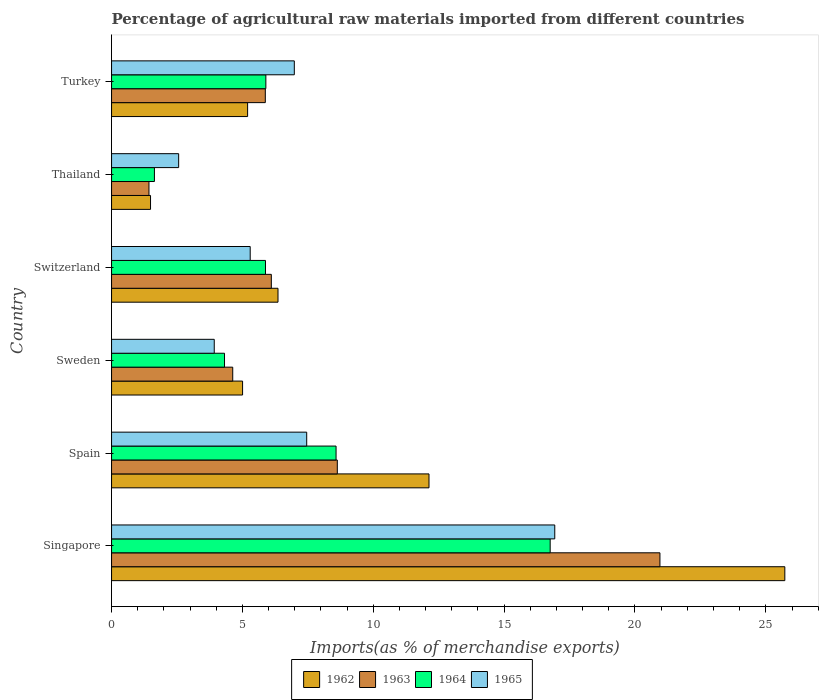Are the number of bars on each tick of the Y-axis equal?
Your answer should be compact. Yes. How many bars are there on the 4th tick from the bottom?
Offer a terse response. 4. What is the label of the 5th group of bars from the top?
Your answer should be very brief. Spain. What is the percentage of imports to different countries in 1963 in Turkey?
Offer a very short reply. 5.87. Across all countries, what is the maximum percentage of imports to different countries in 1964?
Offer a terse response. 16.76. Across all countries, what is the minimum percentage of imports to different countries in 1962?
Give a very brief answer. 1.49. In which country was the percentage of imports to different countries in 1963 maximum?
Your answer should be compact. Singapore. In which country was the percentage of imports to different countries in 1963 minimum?
Keep it short and to the point. Thailand. What is the total percentage of imports to different countries in 1965 in the graph?
Ensure brevity in your answer.  43.16. What is the difference between the percentage of imports to different countries in 1964 in Singapore and that in Turkey?
Ensure brevity in your answer.  10.86. What is the difference between the percentage of imports to different countries in 1962 in Turkey and the percentage of imports to different countries in 1965 in Sweden?
Offer a terse response. 1.27. What is the average percentage of imports to different countries in 1965 per country?
Offer a terse response. 7.19. What is the difference between the percentage of imports to different countries in 1962 and percentage of imports to different countries in 1965 in Thailand?
Your response must be concise. -1.08. What is the ratio of the percentage of imports to different countries in 1965 in Singapore to that in Turkey?
Ensure brevity in your answer.  2.43. Is the difference between the percentage of imports to different countries in 1962 in Singapore and Thailand greater than the difference between the percentage of imports to different countries in 1965 in Singapore and Thailand?
Make the answer very short. Yes. What is the difference between the highest and the second highest percentage of imports to different countries in 1962?
Offer a very short reply. 13.6. What is the difference between the highest and the lowest percentage of imports to different countries in 1963?
Your answer should be compact. 19.52. Is it the case that in every country, the sum of the percentage of imports to different countries in 1964 and percentage of imports to different countries in 1962 is greater than the sum of percentage of imports to different countries in 1965 and percentage of imports to different countries in 1963?
Give a very brief answer. No. What does the 1st bar from the top in Singapore represents?
Offer a terse response. 1965. What does the 1st bar from the bottom in Turkey represents?
Provide a succinct answer. 1962. Is it the case that in every country, the sum of the percentage of imports to different countries in 1962 and percentage of imports to different countries in 1965 is greater than the percentage of imports to different countries in 1964?
Offer a terse response. Yes. How many bars are there?
Provide a succinct answer. 24. Are all the bars in the graph horizontal?
Provide a succinct answer. Yes. How many countries are there in the graph?
Your answer should be very brief. 6. Does the graph contain grids?
Your answer should be compact. No. Where does the legend appear in the graph?
Your answer should be very brief. Bottom center. How many legend labels are there?
Your response must be concise. 4. How are the legend labels stacked?
Your response must be concise. Horizontal. What is the title of the graph?
Ensure brevity in your answer.  Percentage of agricultural raw materials imported from different countries. What is the label or title of the X-axis?
Give a very brief answer. Imports(as % of merchandise exports). What is the label or title of the Y-axis?
Give a very brief answer. Country. What is the Imports(as % of merchandise exports) of 1962 in Singapore?
Offer a very short reply. 25.73. What is the Imports(as % of merchandise exports) in 1963 in Singapore?
Your answer should be very brief. 20.95. What is the Imports(as % of merchandise exports) in 1964 in Singapore?
Your answer should be very brief. 16.76. What is the Imports(as % of merchandise exports) of 1965 in Singapore?
Provide a short and direct response. 16.93. What is the Imports(as % of merchandise exports) in 1962 in Spain?
Your response must be concise. 12.13. What is the Imports(as % of merchandise exports) in 1963 in Spain?
Offer a terse response. 8.63. What is the Imports(as % of merchandise exports) of 1964 in Spain?
Your response must be concise. 8.58. What is the Imports(as % of merchandise exports) in 1965 in Spain?
Keep it short and to the point. 7.46. What is the Imports(as % of merchandise exports) of 1962 in Sweden?
Offer a very short reply. 5.01. What is the Imports(as % of merchandise exports) of 1963 in Sweden?
Keep it short and to the point. 4.63. What is the Imports(as % of merchandise exports) of 1964 in Sweden?
Offer a very short reply. 4.32. What is the Imports(as % of merchandise exports) of 1965 in Sweden?
Offer a terse response. 3.92. What is the Imports(as % of merchandise exports) in 1962 in Switzerland?
Ensure brevity in your answer.  6.36. What is the Imports(as % of merchandise exports) in 1963 in Switzerland?
Provide a succinct answer. 6.1. What is the Imports(as % of merchandise exports) of 1964 in Switzerland?
Your answer should be very brief. 5.88. What is the Imports(as % of merchandise exports) in 1965 in Switzerland?
Make the answer very short. 5.3. What is the Imports(as % of merchandise exports) in 1962 in Thailand?
Offer a terse response. 1.49. What is the Imports(as % of merchandise exports) in 1963 in Thailand?
Keep it short and to the point. 1.43. What is the Imports(as % of merchandise exports) of 1964 in Thailand?
Your answer should be compact. 1.64. What is the Imports(as % of merchandise exports) in 1965 in Thailand?
Give a very brief answer. 2.56. What is the Imports(as % of merchandise exports) in 1962 in Turkey?
Your response must be concise. 5.2. What is the Imports(as % of merchandise exports) of 1963 in Turkey?
Ensure brevity in your answer.  5.87. What is the Imports(as % of merchandise exports) of 1964 in Turkey?
Your answer should be very brief. 5.9. What is the Imports(as % of merchandise exports) of 1965 in Turkey?
Provide a succinct answer. 6.98. Across all countries, what is the maximum Imports(as % of merchandise exports) of 1962?
Provide a short and direct response. 25.73. Across all countries, what is the maximum Imports(as % of merchandise exports) in 1963?
Provide a short and direct response. 20.95. Across all countries, what is the maximum Imports(as % of merchandise exports) in 1964?
Your answer should be very brief. 16.76. Across all countries, what is the maximum Imports(as % of merchandise exports) in 1965?
Keep it short and to the point. 16.93. Across all countries, what is the minimum Imports(as % of merchandise exports) in 1962?
Provide a short and direct response. 1.49. Across all countries, what is the minimum Imports(as % of merchandise exports) in 1963?
Your answer should be compact. 1.43. Across all countries, what is the minimum Imports(as % of merchandise exports) in 1964?
Ensure brevity in your answer.  1.64. Across all countries, what is the minimum Imports(as % of merchandise exports) of 1965?
Your answer should be compact. 2.56. What is the total Imports(as % of merchandise exports) in 1962 in the graph?
Keep it short and to the point. 55.91. What is the total Imports(as % of merchandise exports) in 1963 in the graph?
Offer a terse response. 47.62. What is the total Imports(as % of merchandise exports) in 1964 in the graph?
Provide a succinct answer. 43.07. What is the total Imports(as % of merchandise exports) of 1965 in the graph?
Give a very brief answer. 43.16. What is the difference between the Imports(as % of merchandise exports) in 1962 in Singapore and that in Spain?
Offer a very short reply. 13.6. What is the difference between the Imports(as % of merchandise exports) of 1963 in Singapore and that in Spain?
Offer a very short reply. 12.33. What is the difference between the Imports(as % of merchandise exports) in 1964 in Singapore and that in Spain?
Your answer should be compact. 8.18. What is the difference between the Imports(as % of merchandise exports) of 1965 in Singapore and that in Spain?
Provide a short and direct response. 9.48. What is the difference between the Imports(as % of merchandise exports) in 1962 in Singapore and that in Sweden?
Offer a very short reply. 20.72. What is the difference between the Imports(as % of merchandise exports) of 1963 in Singapore and that in Sweden?
Ensure brevity in your answer.  16.32. What is the difference between the Imports(as % of merchandise exports) in 1964 in Singapore and that in Sweden?
Ensure brevity in your answer.  12.44. What is the difference between the Imports(as % of merchandise exports) in 1965 in Singapore and that in Sweden?
Offer a terse response. 13.01. What is the difference between the Imports(as % of merchandise exports) in 1962 in Singapore and that in Switzerland?
Offer a terse response. 19.37. What is the difference between the Imports(as % of merchandise exports) of 1963 in Singapore and that in Switzerland?
Your answer should be very brief. 14.85. What is the difference between the Imports(as % of merchandise exports) in 1964 in Singapore and that in Switzerland?
Keep it short and to the point. 10.88. What is the difference between the Imports(as % of merchandise exports) in 1965 in Singapore and that in Switzerland?
Give a very brief answer. 11.64. What is the difference between the Imports(as % of merchandise exports) in 1962 in Singapore and that in Thailand?
Your answer should be compact. 24.24. What is the difference between the Imports(as % of merchandise exports) in 1963 in Singapore and that in Thailand?
Ensure brevity in your answer.  19.52. What is the difference between the Imports(as % of merchandise exports) in 1964 in Singapore and that in Thailand?
Give a very brief answer. 15.12. What is the difference between the Imports(as % of merchandise exports) of 1965 in Singapore and that in Thailand?
Offer a very short reply. 14.37. What is the difference between the Imports(as % of merchandise exports) of 1962 in Singapore and that in Turkey?
Provide a short and direct response. 20.53. What is the difference between the Imports(as % of merchandise exports) in 1963 in Singapore and that in Turkey?
Provide a short and direct response. 15.08. What is the difference between the Imports(as % of merchandise exports) in 1964 in Singapore and that in Turkey?
Your response must be concise. 10.86. What is the difference between the Imports(as % of merchandise exports) in 1965 in Singapore and that in Turkey?
Ensure brevity in your answer.  9.95. What is the difference between the Imports(as % of merchandise exports) of 1962 in Spain and that in Sweden?
Keep it short and to the point. 7.12. What is the difference between the Imports(as % of merchandise exports) of 1963 in Spain and that in Sweden?
Give a very brief answer. 4. What is the difference between the Imports(as % of merchandise exports) in 1964 in Spain and that in Sweden?
Your response must be concise. 4.26. What is the difference between the Imports(as % of merchandise exports) of 1965 in Spain and that in Sweden?
Offer a terse response. 3.53. What is the difference between the Imports(as % of merchandise exports) in 1962 in Spain and that in Switzerland?
Your answer should be compact. 5.77. What is the difference between the Imports(as % of merchandise exports) of 1963 in Spain and that in Switzerland?
Make the answer very short. 2.52. What is the difference between the Imports(as % of merchandise exports) in 1964 in Spain and that in Switzerland?
Provide a short and direct response. 2.7. What is the difference between the Imports(as % of merchandise exports) in 1965 in Spain and that in Switzerland?
Ensure brevity in your answer.  2.16. What is the difference between the Imports(as % of merchandise exports) of 1962 in Spain and that in Thailand?
Ensure brevity in your answer.  10.64. What is the difference between the Imports(as % of merchandise exports) in 1963 in Spain and that in Thailand?
Give a very brief answer. 7.2. What is the difference between the Imports(as % of merchandise exports) in 1964 in Spain and that in Thailand?
Your response must be concise. 6.94. What is the difference between the Imports(as % of merchandise exports) of 1965 in Spain and that in Thailand?
Make the answer very short. 4.89. What is the difference between the Imports(as % of merchandise exports) of 1962 in Spain and that in Turkey?
Make the answer very short. 6.93. What is the difference between the Imports(as % of merchandise exports) in 1963 in Spain and that in Turkey?
Provide a short and direct response. 2.75. What is the difference between the Imports(as % of merchandise exports) of 1964 in Spain and that in Turkey?
Your response must be concise. 2.68. What is the difference between the Imports(as % of merchandise exports) of 1965 in Spain and that in Turkey?
Your answer should be very brief. 0.47. What is the difference between the Imports(as % of merchandise exports) of 1962 in Sweden and that in Switzerland?
Your response must be concise. -1.35. What is the difference between the Imports(as % of merchandise exports) of 1963 in Sweden and that in Switzerland?
Your answer should be compact. -1.47. What is the difference between the Imports(as % of merchandise exports) in 1964 in Sweden and that in Switzerland?
Your answer should be compact. -1.57. What is the difference between the Imports(as % of merchandise exports) of 1965 in Sweden and that in Switzerland?
Ensure brevity in your answer.  -1.37. What is the difference between the Imports(as % of merchandise exports) in 1962 in Sweden and that in Thailand?
Your answer should be very brief. 3.52. What is the difference between the Imports(as % of merchandise exports) in 1963 in Sweden and that in Thailand?
Your answer should be compact. 3.2. What is the difference between the Imports(as % of merchandise exports) in 1964 in Sweden and that in Thailand?
Ensure brevity in your answer.  2.68. What is the difference between the Imports(as % of merchandise exports) of 1965 in Sweden and that in Thailand?
Your answer should be very brief. 1.36. What is the difference between the Imports(as % of merchandise exports) of 1962 in Sweden and that in Turkey?
Your response must be concise. -0.19. What is the difference between the Imports(as % of merchandise exports) of 1963 in Sweden and that in Turkey?
Provide a succinct answer. -1.24. What is the difference between the Imports(as % of merchandise exports) in 1964 in Sweden and that in Turkey?
Keep it short and to the point. -1.58. What is the difference between the Imports(as % of merchandise exports) of 1965 in Sweden and that in Turkey?
Your answer should be very brief. -3.06. What is the difference between the Imports(as % of merchandise exports) in 1962 in Switzerland and that in Thailand?
Ensure brevity in your answer.  4.87. What is the difference between the Imports(as % of merchandise exports) in 1963 in Switzerland and that in Thailand?
Offer a very short reply. 4.68. What is the difference between the Imports(as % of merchandise exports) of 1964 in Switzerland and that in Thailand?
Make the answer very short. 4.24. What is the difference between the Imports(as % of merchandise exports) of 1965 in Switzerland and that in Thailand?
Make the answer very short. 2.73. What is the difference between the Imports(as % of merchandise exports) in 1962 in Switzerland and that in Turkey?
Provide a short and direct response. 1.16. What is the difference between the Imports(as % of merchandise exports) of 1963 in Switzerland and that in Turkey?
Keep it short and to the point. 0.23. What is the difference between the Imports(as % of merchandise exports) in 1964 in Switzerland and that in Turkey?
Your answer should be compact. -0.01. What is the difference between the Imports(as % of merchandise exports) in 1965 in Switzerland and that in Turkey?
Make the answer very short. -1.69. What is the difference between the Imports(as % of merchandise exports) of 1962 in Thailand and that in Turkey?
Your answer should be very brief. -3.71. What is the difference between the Imports(as % of merchandise exports) of 1963 in Thailand and that in Turkey?
Your response must be concise. -4.45. What is the difference between the Imports(as % of merchandise exports) of 1964 in Thailand and that in Turkey?
Offer a very short reply. -4.26. What is the difference between the Imports(as % of merchandise exports) of 1965 in Thailand and that in Turkey?
Make the answer very short. -4.42. What is the difference between the Imports(as % of merchandise exports) in 1962 in Singapore and the Imports(as % of merchandise exports) in 1963 in Spain?
Offer a very short reply. 17.1. What is the difference between the Imports(as % of merchandise exports) of 1962 in Singapore and the Imports(as % of merchandise exports) of 1964 in Spain?
Ensure brevity in your answer.  17.15. What is the difference between the Imports(as % of merchandise exports) of 1962 in Singapore and the Imports(as % of merchandise exports) of 1965 in Spain?
Ensure brevity in your answer.  18.27. What is the difference between the Imports(as % of merchandise exports) of 1963 in Singapore and the Imports(as % of merchandise exports) of 1964 in Spain?
Your answer should be compact. 12.38. What is the difference between the Imports(as % of merchandise exports) of 1963 in Singapore and the Imports(as % of merchandise exports) of 1965 in Spain?
Offer a very short reply. 13.5. What is the difference between the Imports(as % of merchandise exports) of 1964 in Singapore and the Imports(as % of merchandise exports) of 1965 in Spain?
Offer a terse response. 9.3. What is the difference between the Imports(as % of merchandise exports) of 1962 in Singapore and the Imports(as % of merchandise exports) of 1963 in Sweden?
Provide a short and direct response. 21.09. What is the difference between the Imports(as % of merchandise exports) in 1962 in Singapore and the Imports(as % of merchandise exports) in 1964 in Sweden?
Provide a succinct answer. 21.41. What is the difference between the Imports(as % of merchandise exports) of 1962 in Singapore and the Imports(as % of merchandise exports) of 1965 in Sweden?
Your answer should be compact. 21.8. What is the difference between the Imports(as % of merchandise exports) in 1963 in Singapore and the Imports(as % of merchandise exports) in 1964 in Sweden?
Make the answer very short. 16.64. What is the difference between the Imports(as % of merchandise exports) of 1963 in Singapore and the Imports(as % of merchandise exports) of 1965 in Sweden?
Make the answer very short. 17.03. What is the difference between the Imports(as % of merchandise exports) in 1964 in Singapore and the Imports(as % of merchandise exports) in 1965 in Sweden?
Provide a succinct answer. 12.83. What is the difference between the Imports(as % of merchandise exports) in 1962 in Singapore and the Imports(as % of merchandise exports) in 1963 in Switzerland?
Your answer should be very brief. 19.62. What is the difference between the Imports(as % of merchandise exports) of 1962 in Singapore and the Imports(as % of merchandise exports) of 1964 in Switzerland?
Provide a succinct answer. 19.84. What is the difference between the Imports(as % of merchandise exports) in 1962 in Singapore and the Imports(as % of merchandise exports) in 1965 in Switzerland?
Ensure brevity in your answer.  20.43. What is the difference between the Imports(as % of merchandise exports) in 1963 in Singapore and the Imports(as % of merchandise exports) in 1964 in Switzerland?
Make the answer very short. 15.07. What is the difference between the Imports(as % of merchandise exports) of 1963 in Singapore and the Imports(as % of merchandise exports) of 1965 in Switzerland?
Keep it short and to the point. 15.66. What is the difference between the Imports(as % of merchandise exports) of 1964 in Singapore and the Imports(as % of merchandise exports) of 1965 in Switzerland?
Your response must be concise. 11.46. What is the difference between the Imports(as % of merchandise exports) of 1962 in Singapore and the Imports(as % of merchandise exports) of 1963 in Thailand?
Provide a short and direct response. 24.3. What is the difference between the Imports(as % of merchandise exports) of 1962 in Singapore and the Imports(as % of merchandise exports) of 1964 in Thailand?
Offer a very short reply. 24.09. What is the difference between the Imports(as % of merchandise exports) in 1962 in Singapore and the Imports(as % of merchandise exports) in 1965 in Thailand?
Offer a very short reply. 23.16. What is the difference between the Imports(as % of merchandise exports) in 1963 in Singapore and the Imports(as % of merchandise exports) in 1964 in Thailand?
Keep it short and to the point. 19.32. What is the difference between the Imports(as % of merchandise exports) of 1963 in Singapore and the Imports(as % of merchandise exports) of 1965 in Thailand?
Offer a very short reply. 18.39. What is the difference between the Imports(as % of merchandise exports) in 1964 in Singapore and the Imports(as % of merchandise exports) in 1965 in Thailand?
Provide a succinct answer. 14.2. What is the difference between the Imports(as % of merchandise exports) of 1962 in Singapore and the Imports(as % of merchandise exports) of 1963 in Turkey?
Your answer should be very brief. 19.85. What is the difference between the Imports(as % of merchandise exports) of 1962 in Singapore and the Imports(as % of merchandise exports) of 1964 in Turkey?
Give a very brief answer. 19.83. What is the difference between the Imports(as % of merchandise exports) of 1962 in Singapore and the Imports(as % of merchandise exports) of 1965 in Turkey?
Keep it short and to the point. 18.74. What is the difference between the Imports(as % of merchandise exports) of 1963 in Singapore and the Imports(as % of merchandise exports) of 1964 in Turkey?
Offer a terse response. 15.06. What is the difference between the Imports(as % of merchandise exports) of 1963 in Singapore and the Imports(as % of merchandise exports) of 1965 in Turkey?
Give a very brief answer. 13.97. What is the difference between the Imports(as % of merchandise exports) in 1964 in Singapore and the Imports(as % of merchandise exports) in 1965 in Turkey?
Your response must be concise. 9.78. What is the difference between the Imports(as % of merchandise exports) in 1962 in Spain and the Imports(as % of merchandise exports) in 1963 in Sweden?
Keep it short and to the point. 7.5. What is the difference between the Imports(as % of merchandise exports) in 1962 in Spain and the Imports(as % of merchandise exports) in 1964 in Sweden?
Provide a succinct answer. 7.81. What is the difference between the Imports(as % of merchandise exports) of 1962 in Spain and the Imports(as % of merchandise exports) of 1965 in Sweden?
Offer a very short reply. 8.21. What is the difference between the Imports(as % of merchandise exports) in 1963 in Spain and the Imports(as % of merchandise exports) in 1964 in Sweden?
Give a very brief answer. 4.31. What is the difference between the Imports(as % of merchandise exports) of 1963 in Spain and the Imports(as % of merchandise exports) of 1965 in Sweden?
Provide a succinct answer. 4.7. What is the difference between the Imports(as % of merchandise exports) of 1964 in Spain and the Imports(as % of merchandise exports) of 1965 in Sweden?
Provide a succinct answer. 4.65. What is the difference between the Imports(as % of merchandise exports) in 1962 in Spain and the Imports(as % of merchandise exports) in 1963 in Switzerland?
Offer a terse response. 6.02. What is the difference between the Imports(as % of merchandise exports) of 1962 in Spain and the Imports(as % of merchandise exports) of 1964 in Switzerland?
Give a very brief answer. 6.25. What is the difference between the Imports(as % of merchandise exports) in 1962 in Spain and the Imports(as % of merchandise exports) in 1965 in Switzerland?
Your response must be concise. 6.83. What is the difference between the Imports(as % of merchandise exports) of 1963 in Spain and the Imports(as % of merchandise exports) of 1964 in Switzerland?
Provide a short and direct response. 2.74. What is the difference between the Imports(as % of merchandise exports) in 1963 in Spain and the Imports(as % of merchandise exports) in 1965 in Switzerland?
Make the answer very short. 3.33. What is the difference between the Imports(as % of merchandise exports) of 1964 in Spain and the Imports(as % of merchandise exports) of 1965 in Switzerland?
Keep it short and to the point. 3.28. What is the difference between the Imports(as % of merchandise exports) of 1962 in Spain and the Imports(as % of merchandise exports) of 1963 in Thailand?
Your answer should be compact. 10.7. What is the difference between the Imports(as % of merchandise exports) of 1962 in Spain and the Imports(as % of merchandise exports) of 1964 in Thailand?
Your answer should be compact. 10.49. What is the difference between the Imports(as % of merchandise exports) of 1962 in Spain and the Imports(as % of merchandise exports) of 1965 in Thailand?
Your response must be concise. 9.57. What is the difference between the Imports(as % of merchandise exports) in 1963 in Spain and the Imports(as % of merchandise exports) in 1964 in Thailand?
Offer a very short reply. 6.99. What is the difference between the Imports(as % of merchandise exports) of 1963 in Spain and the Imports(as % of merchandise exports) of 1965 in Thailand?
Your response must be concise. 6.06. What is the difference between the Imports(as % of merchandise exports) in 1964 in Spain and the Imports(as % of merchandise exports) in 1965 in Thailand?
Provide a succinct answer. 6.01. What is the difference between the Imports(as % of merchandise exports) of 1962 in Spain and the Imports(as % of merchandise exports) of 1963 in Turkey?
Ensure brevity in your answer.  6.25. What is the difference between the Imports(as % of merchandise exports) of 1962 in Spain and the Imports(as % of merchandise exports) of 1964 in Turkey?
Your answer should be compact. 6.23. What is the difference between the Imports(as % of merchandise exports) of 1962 in Spain and the Imports(as % of merchandise exports) of 1965 in Turkey?
Your response must be concise. 5.15. What is the difference between the Imports(as % of merchandise exports) in 1963 in Spain and the Imports(as % of merchandise exports) in 1964 in Turkey?
Make the answer very short. 2.73. What is the difference between the Imports(as % of merchandise exports) in 1963 in Spain and the Imports(as % of merchandise exports) in 1965 in Turkey?
Your answer should be very brief. 1.64. What is the difference between the Imports(as % of merchandise exports) of 1964 in Spain and the Imports(as % of merchandise exports) of 1965 in Turkey?
Offer a terse response. 1.6. What is the difference between the Imports(as % of merchandise exports) in 1962 in Sweden and the Imports(as % of merchandise exports) in 1963 in Switzerland?
Offer a very short reply. -1.1. What is the difference between the Imports(as % of merchandise exports) of 1962 in Sweden and the Imports(as % of merchandise exports) of 1964 in Switzerland?
Your answer should be compact. -0.88. What is the difference between the Imports(as % of merchandise exports) in 1962 in Sweden and the Imports(as % of merchandise exports) in 1965 in Switzerland?
Make the answer very short. -0.29. What is the difference between the Imports(as % of merchandise exports) of 1963 in Sweden and the Imports(as % of merchandise exports) of 1964 in Switzerland?
Provide a short and direct response. -1.25. What is the difference between the Imports(as % of merchandise exports) of 1963 in Sweden and the Imports(as % of merchandise exports) of 1965 in Switzerland?
Keep it short and to the point. -0.67. What is the difference between the Imports(as % of merchandise exports) in 1964 in Sweden and the Imports(as % of merchandise exports) in 1965 in Switzerland?
Offer a very short reply. -0.98. What is the difference between the Imports(as % of merchandise exports) of 1962 in Sweden and the Imports(as % of merchandise exports) of 1963 in Thailand?
Provide a succinct answer. 3.58. What is the difference between the Imports(as % of merchandise exports) of 1962 in Sweden and the Imports(as % of merchandise exports) of 1964 in Thailand?
Ensure brevity in your answer.  3.37. What is the difference between the Imports(as % of merchandise exports) in 1962 in Sweden and the Imports(as % of merchandise exports) in 1965 in Thailand?
Offer a terse response. 2.44. What is the difference between the Imports(as % of merchandise exports) in 1963 in Sweden and the Imports(as % of merchandise exports) in 1964 in Thailand?
Your answer should be compact. 2.99. What is the difference between the Imports(as % of merchandise exports) in 1963 in Sweden and the Imports(as % of merchandise exports) in 1965 in Thailand?
Your answer should be very brief. 2.07. What is the difference between the Imports(as % of merchandise exports) in 1964 in Sweden and the Imports(as % of merchandise exports) in 1965 in Thailand?
Offer a very short reply. 1.75. What is the difference between the Imports(as % of merchandise exports) in 1962 in Sweden and the Imports(as % of merchandise exports) in 1963 in Turkey?
Your answer should be compact. -0.87. What is the difference between the Imports(as % of merchandise exports) in 1962 in Sweden and the Imports(as % of merchandise exports) in 1964 in Turkey?
Give a very brief answer. -0.89. What is the difference between the Imports(as % of merchandise exports) of 1962 in Sweden and the Imports(as % of merchandise exports) of 1965 in Turkey?
Your response must be concise. -1.98. What is the difference between the Imports(as % of merchandise exports) in 1963 in Sweden and the Imports(as % of merchandise exports) in 1964 in Turkey?
Offer a terse response. -1.27. What is the difference between the Imports(as % of merchandise exports) of 1963 in Sweden and the Imports(as % of merchandise exports) of 1965 in Turkey?
Offer a terse response. -2.35. What is the difference between the Imports(as % of merchandise exports) of 1964 in Sweden and the Imports(as % of merchandise exports) of 1965 in Turkey?
Your answer should be very brief. -2.67. What is the difference between the Imports(as % of merchandise exports) in 1962 in Switzerland and the Imports(as % of merchandise exports) in 1963 in Thailand?
Provide a short and direct response. 4.93. What is the difference between the Imports(as % of merchandise exports) in 1962 in Switzerland and the Imports(as % of merchandise exports) in 1964 in Thailand?
Give a very brief answer. 4.72. What is the difference between the Imports(as % of merchandise exports) in 1962 in Switzerland and the Imports(as % of merchandise exports) in 1965 in Thailand?
Your answer should be compact. 3.8. What is the difference between the Imports(as % of merchandise exports) of 1963 in Switzerland and the Imports(as % of merchandise exports) of 1964 in Thailand?
Keep it short and to the point. 4.47. What is the difference between the Imports(as % of merchandise exports) of 1963 in Switzerland and the Imports(as % of merchandise exports) of 1965 in Thailand?
Your answer should be compact. 3.54. What is the difference between the Imports(as % of merchandise exports) of 1964 in Switzerland and the Imports(as % of merchandise exports) of 1965 in Thailand?
Your response must be concise. 3.32. What is the difference between the Imports(as % of merchandise exports) in 1962 in Switzerland and the Imports(as % of merchandise exports) in 1963 in Turkey?
Ensure brevity in your answer.  0.49. What is the difference between the Imports(as % of merchandise exports) in 1962 in Switzerland and the Imports(as % of merchandise exports) in 1964 in Turkey?
Give a very brief answer. 0.46. What is the difference between the Imports(as % of merchandise exports) of 1962 in Switzerland and the Imports(as % of merchandise exports) of 1965 in Turkey?
Ensure brevity in your answer.  -0.62. What is the difference between the Imports(as % of merchandise exports) of 1963 in Switzerland and the Imports(as % of merchandise exports) of 1964 in Turkey?
Provide a short and direct response. 0.21. What is the difference between the Imports(as % of merchandise exports) of 1963 in Switzerland and the Imports(as % of merchandise exports) of 1965 in Turkey?
Provide a short and direct response. -0.88. What is the difference between the Imports(as % of merchandise exports) in 1964 in Switzerland and the Imports(as % of merchandise exports) in 1965 in Turkey?
Keep it short and to the point. -1.1. What is the difference between the Imports(as % of merchandise exports) of 1962 in Thailand and the Imports(as % of merchandise exports) of 1963 in Turkey?
Ensure brevity in your answer.  -4.39. What is the difference between the Imports(as % of merchandise exports) in 1962 in Thailand and the Imports(as % of merchandise exports) in 1964 in Turkey?
Make the answer very short. -4.41. What is the difference between the Imports(as % of merchandise exports) of 1962 in Thailand and the Imports(as % of merchandise exports) of 1965 in Turkey?
Offer a very short reply. -5.49. What is the difference between the Imports(as % of merchandise exports) of 1963 in Thailand and the Imports(as % of merchandise exports) of 1964 in Turkey?
Make the answer very short. -4.47. What is the difference between the Imports(as % of merchandise exports) of 1963 in Thailand and the Imports(as % of merchandise exports) of 1965 in Turkey?
Your answer should be compact. -5.55. What is the difference between the Imports(as % of merchandise exports) of 1964 in Thailand and the Imports(as % of merchandise exports) of 1965 in Turkey?
Ensure brevity in your answer.  -5.35. What is the average Imports(as % of merchandise exports) of 1962 per country?
Provide a short and direct response. 9.32. What is the average Imports(as % of merchandise exports) of 1963 per country?
Your answer should be very brief. 7.94. What is the average Imports(as % of merchandise exports) of 1964 per country?
Make the answer very short. 7.18. What is the average Imports(as % of merchandise exports) of 1965 per country?
Make the answer very short. 7.19. What is the difference between the Imports(as % of merchandise exports) in 1962 and Imports(as % of merchandise exports) in 1963 in Singapore?
Offer a very short reply. 4.77. What is the difference between the Imports(as % of merchandise exports) in 1962 and Imports(as % of merchandise exports) in 1964 in Singapore?
Your response must be concise. 8.97. What is the difference between the Imports(as % of merchandise exports) of 1962 and Imports(as % of merchandise exports) of 1965 in Singapore?
Provide a succinct answer. 8.79. What is the difference between the Imports(as % of merchandise exports) in 1963 and Imports(as % of merchandise exports) in 1964 in Singapore?
Provide a succinct answer. 4.19. What is the difference between the Imports(as % of merchandise exports) in 1963 and Imports(as % of merchandise exports) in 1965 in Singapore?
Offer a terse response. 4.02. What is the difference between the Imports(as % of merchandise exports) in 1964 and Imports(as % of merchandise exports) in 1965 in Singapore?
Make the answer very short. -0.18. What is the difference between the Imports(as % of merchandise exports) in 1962 and Imports(as % of merchandise exports) in 1963 in Spain?
Your answer should be compact. 3.5. What is the difference between the Imports(as % of merchandise exports) of 1962 and Imports(as % of merchandise exports) of 1964 in Spain?
Ensure brevity in your answer.  3.55. What is the difference between the Imports(as % of merchandise exports) of 1962 and Imports(as % of merchandise exports) of 1965 in Spain?
Keep it short and to the point. 4.67. What is the difference between the Imports(as % of merchandise exports) of 1963 and Imports(as % of merchandise exports) of 1964 in Spain?
Offer a terse response. 0.05. What is the difference between the Imports(as % of merchandise exports) in 1963 and Imports(as % of merchandise exports) in 1965 in Spain?
Give a very brief answer. 1.17. What is the difference between the Imports(as % of merchandise exports) in 1964 and Imports(as % of merchandise exports) in 1965 in Spain?
Make the answer very short. 1.12. What is the difference between the Imports(as % of merchandise exports) of 1962 and Imports(as % of merchandise exports) of 1963 in Sweden?
Offer a terse response. 0.38. What is the difference between the Imports(as % of merchandise exports) in 1962 and Imports(as % of merchandise exports) in 1964 in Sweden?
Provide a short and direct response. 0.69. What is the difference between the Imports(as % of merchandise exports) in 1962 and Imports(as % of merchandise exports) in 1965 in Sweden?
Make the answer very short. 1.08. What is the difference between the Imports(as % of merchandise exports) of 1963 and Imports(as % of merchandise exports) of 1964 in Sweden?
Your answer should be very brief. 0.31. What is the difference between the Imports(as % of merchandise exports) of 1963 and Imports(as % of merchandise exports) of 1965 in Sweden?
Give a very brief answer. 0.71. What is the difference between the Imports(as % of merchandise exports) in 1964 and Imports(as % of merchandise exports) in 1965 in Sweden?
Provide a succinct answer. 0.39. What is the difference between the Imports(as % of merchandise exports) of 1962 and Imports(as % of merchandise exports) of 1963 in Switzerland?
Ensure brevity in your answer.  0.26. What is the difference between the Imports(as % of merchandise exports) in 1962 and Imports(as % of merchandise exports) in 1964 in Switzerland?
Your answer should be compact. 0.48. What is the difference between the Imports(as % of merchandise exports) in 1962 and Imports(as % of merchandise exports) in 1965 in Switzerland?
Your answer should be very brief. 1.06. What is the difference between the Imports(as % of merchandise exports) in 1963 and Imports(as % of merchandise exports) in 1964 in Switzerland?
Provide a succinct answer. 0.22. What is the difference between the Imports(as % of merchandise exports) in 1963 and Imports(as % of merchandise exports) in 1965 in Switzerland?
Your answer should be very brief. 0.81. What is the difference between the Imports(as % of merchandise exports) in 1964 and Imports(as % of merchandise exports) in 1965 in Switzerland?
Provide a succinct answer. 0.58. What is the difference between the Imports(as % of merchandise exports) in 1962 and Imports(as % of merchandise exports) in 1963 in Thailand?
Provide a short and direct response. 0.06. What is the difference between the Imports(as % of merchandise exports) of 1962 and Imports(as % of merchandise exports) of 1964 in Thailand?
Offer a terse response. -0.15. What is the difference between the Imports(as % of merchandise exports) of 1962 and Imports(as % of merchandise exports) of 1965 in Thailand?
Your answer should be compact. -1.08. What is the difference between the Imports(as % of merchandise exports) in 1963 and Imports(as % of merchandise exports) in 1964 in Thailand?
Offer a very short reply. -0.21. What is the difference between the Imports(as % of merchandise exports) in 1963 and Imports(as % of merchandise exports) in 1965 in Thailand?
Keep it short and to the point. -1.13. What is the difference between the Imports(as % of merchandise exports) in 1964 and Imports(as % of merchandise exports) in 1965 in Thailand?
Offer a terse response. -0.93. What is the difference between the Imports(as % of merchandise exports) of 1962 and Imports(as % of merchandise exports) of 1963 in Turkey?
Ensure brevity in your answer.  -0.68. What is the difference between the Imports(as % of merchandise exports) in 1962 and Imports(as % of merchandise exports) in 1964 in Turkey?
Ensure brevity in your answer.  -0.7. What is the difference between the Imports(as % of merchandise exports) of 1962 and Imports(as % of merchandise exports) of 1965 in Turkey?
Provide a succinct answer. -1.78. What is the difference between the Imports(as % of merchandise exports) in 1963 and Imports(as % of merchandise exports) in 1964 in Turkey?
Offer a terse response. -0.02. What is the difference between the Imports(as % of merchandise exports) of 1963 and Imports(as % of merchandise exports) of 1965 in Turkey?
Provide a short and direct response. -1.11. What is the difference between the Imports(as % of merchandise exports) of 1964 and Imports(as % of merchandise exports) of 1965 in Turkey?
Ensure brevity in your answer.  -1.09. What is the ratio of the Imports(as % of merchandise exports) in 1962 in Singapore to that in Spain?
Your answer should be compact. 2.12. What is the ratio of the Imports(as % of merchandise exports) in 1963 in Singapore to that in Spain?
Your answer should be very brief. 2.43. What is the ratio of the Imports(as % of merchandise exports) in 1964 in Singapore to that in Spain?
Give a very brief answer. 1.95. What is the ratio of the Imports(as % of merchandise exports) in 1965 in Singapore to that in Spain?
Your answer should be compact. 2.27. What is the ratio of the Imports(as % of merchandise exports) in 1962 in Singapore to that in Sweden?
Give a very brief answer. 5.14. What is the ratio of the Imports(as % of merchandise exports) in 1963 in Singapore to that in Sweden?
Provide a succinct answer. 4.53. What is the ratio of the Imports(as % of merchandise exports) in 1964 in Singapore to that in Sweden?
Your response must be concise. 3.88. What is the ratio of the Imports(as % of merchandise exports) in 1965 in Singapore to that in Sweden?
Provide a succinct answer. 4.32. What is the ratio of the Imports(as % of merchandise exports) in 1962 in Singapore to that in Switzerland?
Your answer should be compact. 4.04. What is the ratio of the Imports(as % of merchandise exports) in 1963 in Singapore to that in Switzerland?
Give a very brief answer. 3.43. What is the ratio of the Imports(as % of merchandise exports) of 1964 in Singapore to that in Switzerland?
Ensure brevity in your answer.  2.85. What is the ratio of the Imports(as % of merchandise exports) in 1965 in Singapore to that in Switzerland?
Make the answer very short. 3.2. What is the ratio of the Imports(as % of merchandise exports) of 1962 in Singapore to that in Thailand?
Offer a very short reply. 17.28. What is the ratio of the Imports(as % of merchandise exports) in 1963 in Singapore to that in Thailand?
Your response must be concise. 14.66. What is the ratio of the Imports(as % of merchandise exports) in 1964 in Singapore to that in Thailand?
Offer a terse response. 10.23. What is the ratio of the Imports(as % of merchandise exports) in 1965 in Singapore to that in Thailand?
Your response must be concise. 6.6. What is the ratio of the Imports(as % of merchandise exports) of 1962 in Singapore to that in Turkey?
Make the answer very short. 4.95. What is the ratio of the Imports(as % of merchandise exports) in 1963 in Singapore to that in Turkey?
Your answer should be compact. 3.57. What is the ratio of the Imports(as % of merchandise exports) in 1964 in Singapore to that in Turkey?
Your answer should be very brief. 2.84. What is the ratio of the Imports(as % of merchandise exports) of 1965 in Singapore to that in Turkey?
Keep it short and to the point. 2.43. What is the ratio of the Imports(as % of merchandise exports) of 1962 in Spain to that in Sweden?
Provide a succinct answer. 2.42. What is the ratio of the Imports(as % of merchandise exports) in 1963 in Spain to that in Sweden?
Your response must be concise. 1.86. What is the ratio of the Imports(as % of merchandise exports) in 1964 in Spain to that in Sweden?
Provide a short and direct response. 1.99. What is the ratio of the Imports(as % of merchandise exports) in 1965 in Spain to that in Sweden?
Provide a short and direct response. 1.9. What is the ratio of the Imports(as % of merchandise exports) of 1962 in Spain to that in Switzerland?
Keep it short and to the point. 1.91. What is the ratio of the Imports(as % of merchandise exports) in 1963 in Spain to that in Switzerland?
Give a very brief answer. 1.41. What is the ratio of the Imports(as % of merchandise exports) in 1964 in Spain to that in Switzerland?
Offer a very short reply. 1.46. What is the ratio of the Imports(as % of merchandise exports) in 1965 in Spain to that in Switzerland?
Ensure brevity in your answer.  1.41. What is the ratio of the Imports(as % of merchandise exports) in 1962 in Spain to that in Thailand?
Your answer should be very brief. 8.15. What is the ratio of the Imports(as % of merchandise exports) of 1963 in Spain to that in Thailand?
Your response must be concise. 6.03. What is the ratio of the Imports(as % of merchandise exports) of 1964 in Spain to that in Thailand?
Make the answer very short. 5.24. What is the ratio of the Imports(as % of merchandise exports) of 1965 in Spain to that in Thailand?
Provide a succinct answer. 2.91. What is the ratio of the Imports(as % of merchandise exports) in 1962 in Spain to that in Turkey?
Your answer should be very brief. 2.33. What is the ratio of the Imports(as % of merchandise exports) in 1963 in Spain to that in Turkey?
Keep it short and to the point. 1.47. What is the ratio of the Imports(as % of merchandise exports) in 1964 in Spain to that in Turkey?
Provide a succinct answer. 1.46. What is the ratio of the Imports(as % of merchandise exports) of 1965 in Spain to that in Turkey?
Offer a very short reply. 1.07. What is the ratio of the Imports(as % of merchandise exports) in 1962 in Sweden to that in Switzerland?
Your answer should be very brief. 0.79. What is the ratio of the Imports(as % of merchandise exports) of 1963 in Sweden to that in Switzerland?
Provide a succinct answer. 0.76. What is the ratio of the Imports(as % of merchandise exports) of 1964 in Sweden to that in Switzerland?
Offer a very short reply. 0.73. What is the ratio of the Imports(as % of merchandise exports) of 1965 in Sweden to that in Switzerland?
Keep it short and to the point. 0.74. What is the ratio of the Imports(as % of merchandise exports) of 1962 in Sweden to that in Thailand?
Provide a succinct answer. 3.36. What is the ratio of the Imports(as % of merchandise exports) in 1963 in Sweden to that in Thailand?
Your answer should be very brief. 3.24. What is the ratio of the Imports(as % of merchandise exports) in 1964 in Sweden to that in Thailand?
Your answer should be very brief. 2.64. What is the ratio of the Imports(as % of merchandise exports) in 1965 in Sweden to that in Thailand?
Provide a short and direct response. 1.53. What is the ratio of the Imports(as % of merchandise exports) in 1962 in Sweden to that in Turkey?
Your answer should be very brief. 0.96. What is the ratio of the Imports(as % of merchandise exports) of 1963 in Sweden to that in Turkey?
Your answer should be compact. 0.79. What is the ratio of the Imports(as % of merchandise exports) in 1964 in Sweden to that in Turkey?
Your answer should be compact. 0.73. What is the ratio of the Imports(as % of merchandise exports) in 1965 in Sweden to that in Turkey?
Provide a short and direct response. 0.56. What is the ratio of the Imports(as % of merchandise exports) of 1962 in Switzerland to that in Thailand?
Give a very brief answer. 4.27. What is the ratio of the Imports(as % of merchandise exports) of 1963 in Switzerland to that in Thailand?
Make the answer very short. 4.27. What is the ratio of the Imports(as % of merchandise exports) in 1964 in Switzerland to that in Thailand?
Give a very brief answer. 3.59. What is the ratio of the Imports(as % of merchandise exports) in 1965 in Switzerland to that in Thailand?
Offer a terse response. 2.07. What is the ratio of the Imports(as % of merchandise exports) of 1962 in Switzerland to that in Turkey?
Your answer should be compact. 1.22. What is the ratio of the Imports(as % of merchandise exports) of 1963 in Switzerland to that in Turkey?
Make the answer very short. 1.04. What is the ratio of the Imports(as % of merchandise exports) in 1964 in Switzerland to that in Turkey?
Your answer should be very brief. 1. What is the ratio of the Imports(as % of merchandise exports) of 1965 in Switzerland to that in Turkey?
Your answer should be very brief. 0.76. What is the ratio of the Imports(as % of merchandise exports) of 1962 in Thailand to that in Turkey?
Make the answer very short. 0.29. What is the ratio of the Imports(as % of merchandise exports) of 1963 in Thailand to that in Turkey?
Your answer should be very brief. 0.24. What is the ratio of the Imports(as % of merchandise exports) in 1964 in Thailand to that in Turkey?
Make the answer very short. 0.28. What is the ratio of the Imports(as % of merchandise exports) in 1965 in Thailand to that in Turkey?
Keep it short and to the point. 0.37. What is the difference between the highest and the second highest Imports(as % of merchandise exports) in 1962?
Your answer should be very brief. 13.6. What is the difference between the highest and the second highest Imports(as % of merchandise exports) of 1963?
Provide a succinct answer. 12.33. What is the difference between the highest and the second highest Imports(as % of merchandise exports) of 1964?
Provide a short and direct response. 8.18. What is the difference between the highest and the second highest Imports(as % of merchandise exports) of 1965?
Your response must be concise. 9.48. What is the difference between the highest and the lowest Imports(as % of merchandise exports) in 1962?
Keep it short and to the point. 24.24. What is the difference between the highest and the lowest Imports(as % of merchandise exports) in 1963?
Provide a succinct answer. 19.52. What is the difference between the highest and the lowest Imports(as % of merchandise exports) of 1964?
Offer a terse response. 15.12. What is the difference between the highest and the lowest Imports(as % of merchandise exports) in 1965?
Give a very brief answer. 14.37. 